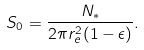Convert formula to latex. <formula><loc_0><loc_0><loc_500><loc_500>S _ { 0 } = \frac { N _ { * } } { 2 \pi r _ { e } ^ { 2 } ( 1 - \epsilon ) } .</formula> 